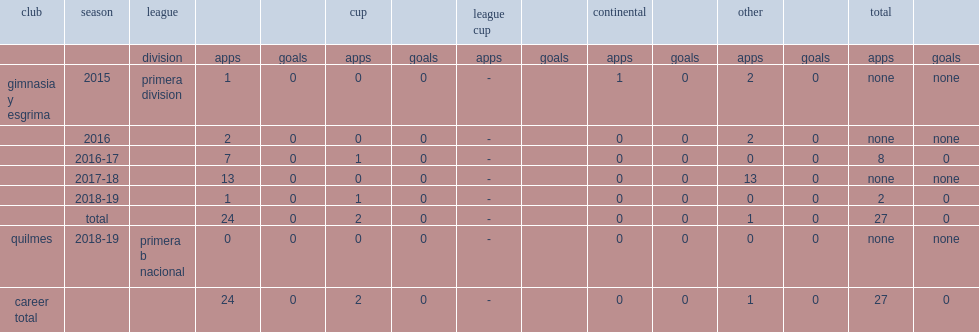Which club did eric ramirez play for in 2015? Gimnasia y esgrima. 